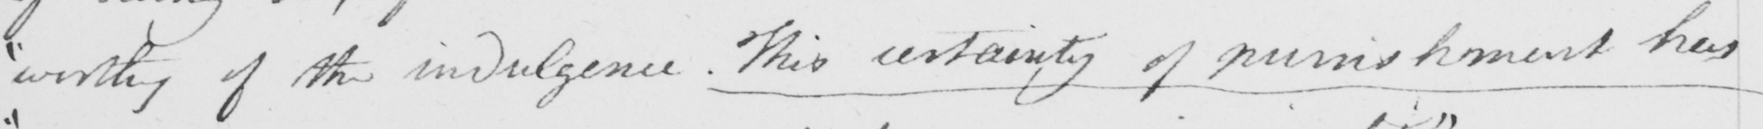Can you read and transcribe this handwriting? " worthy of the indulgence . This certainty of punishment has 